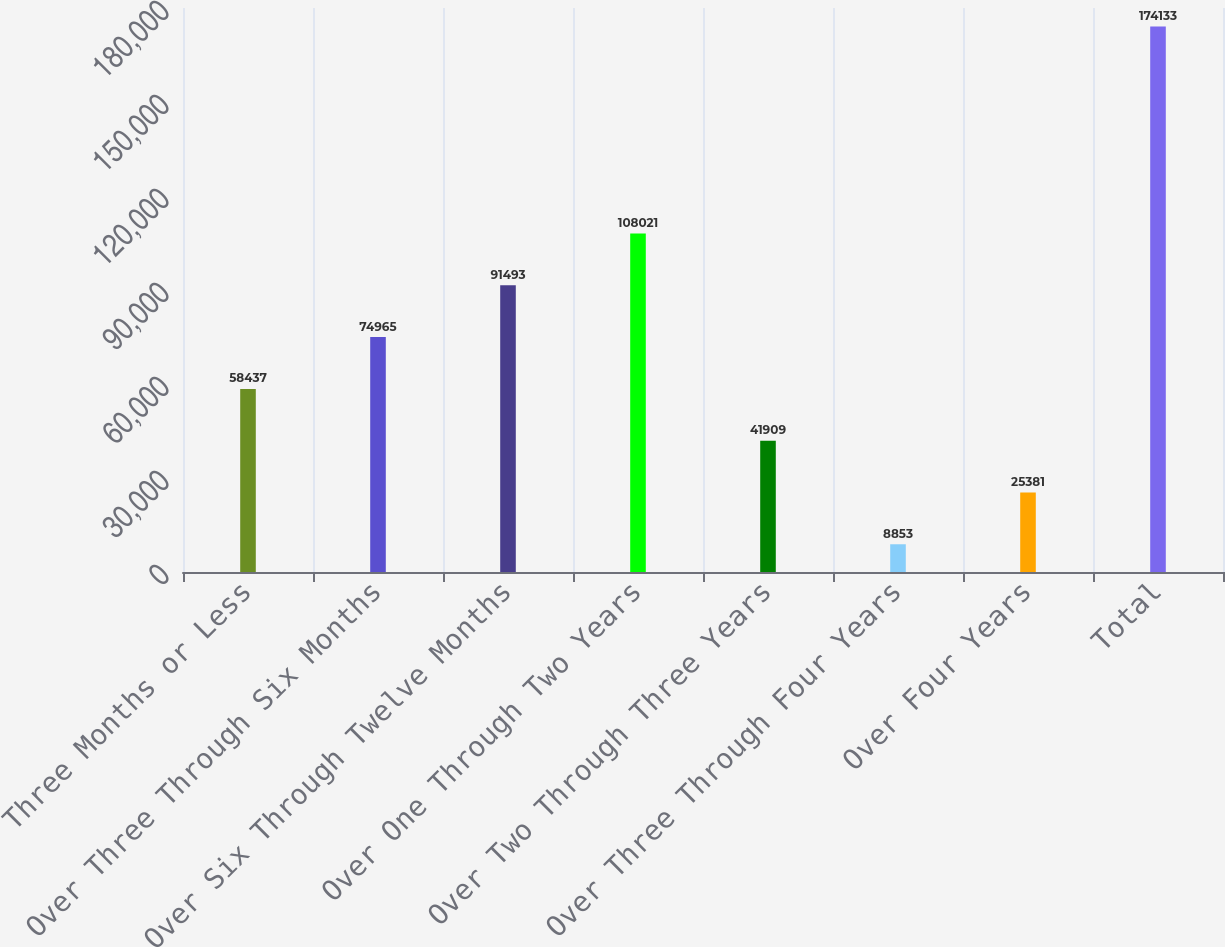Convert chart. <chart><loc_0><loc_0><loc_500><loc_500><bar_chart><fcel>Three Months or Less<fcel>Over Three Through Six Months<fcel>Over Six Through Twelve Months<fcel>Over One Through Two Years<fcel>Over Two Through Three Years<fcel>Over Three Through Four Years<fcel>Over Four Years<fcel>Total<nl><fcel>58437<fcel>74965<fcel>91493<fcel>108021<fcel>41909<fcel>8853<fcel>25381<fcel>174133<nl></chart> 